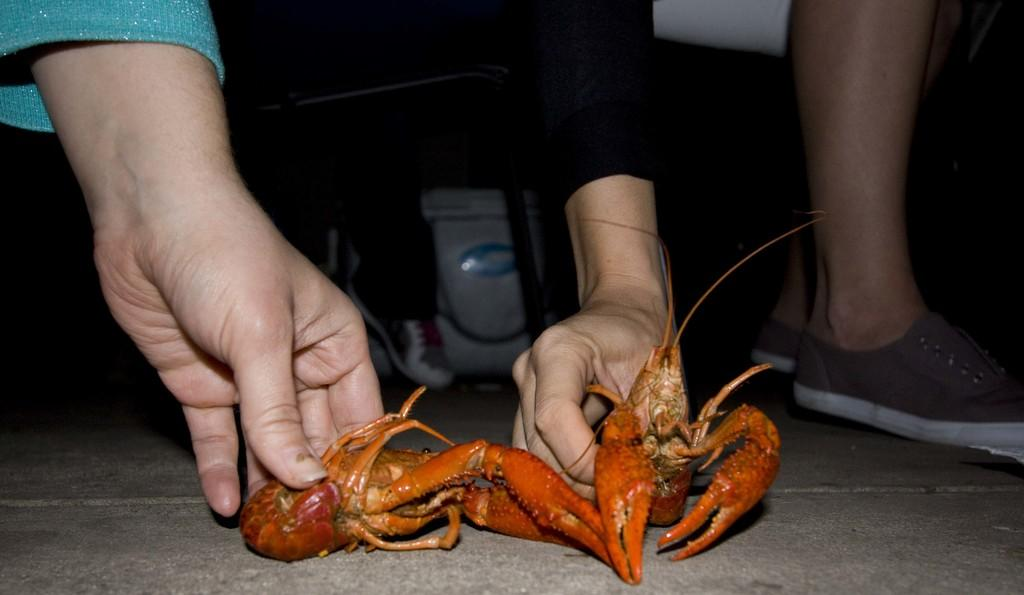How many people are in the image? There are two people in the image. What are the two people doing in the image? The two people are holding an animal. What type of animal are they holding? The animal resembles a crab. What can be seen in the background of the image? There is a white color object in the background of the image. Can you tell me how many boats are in the harbor in the image? There is no harbor or boats present in the image. What type of rake is being used by the people in the image? There is no rake visible in the image; the people are holding an animal that resembles a crab. 